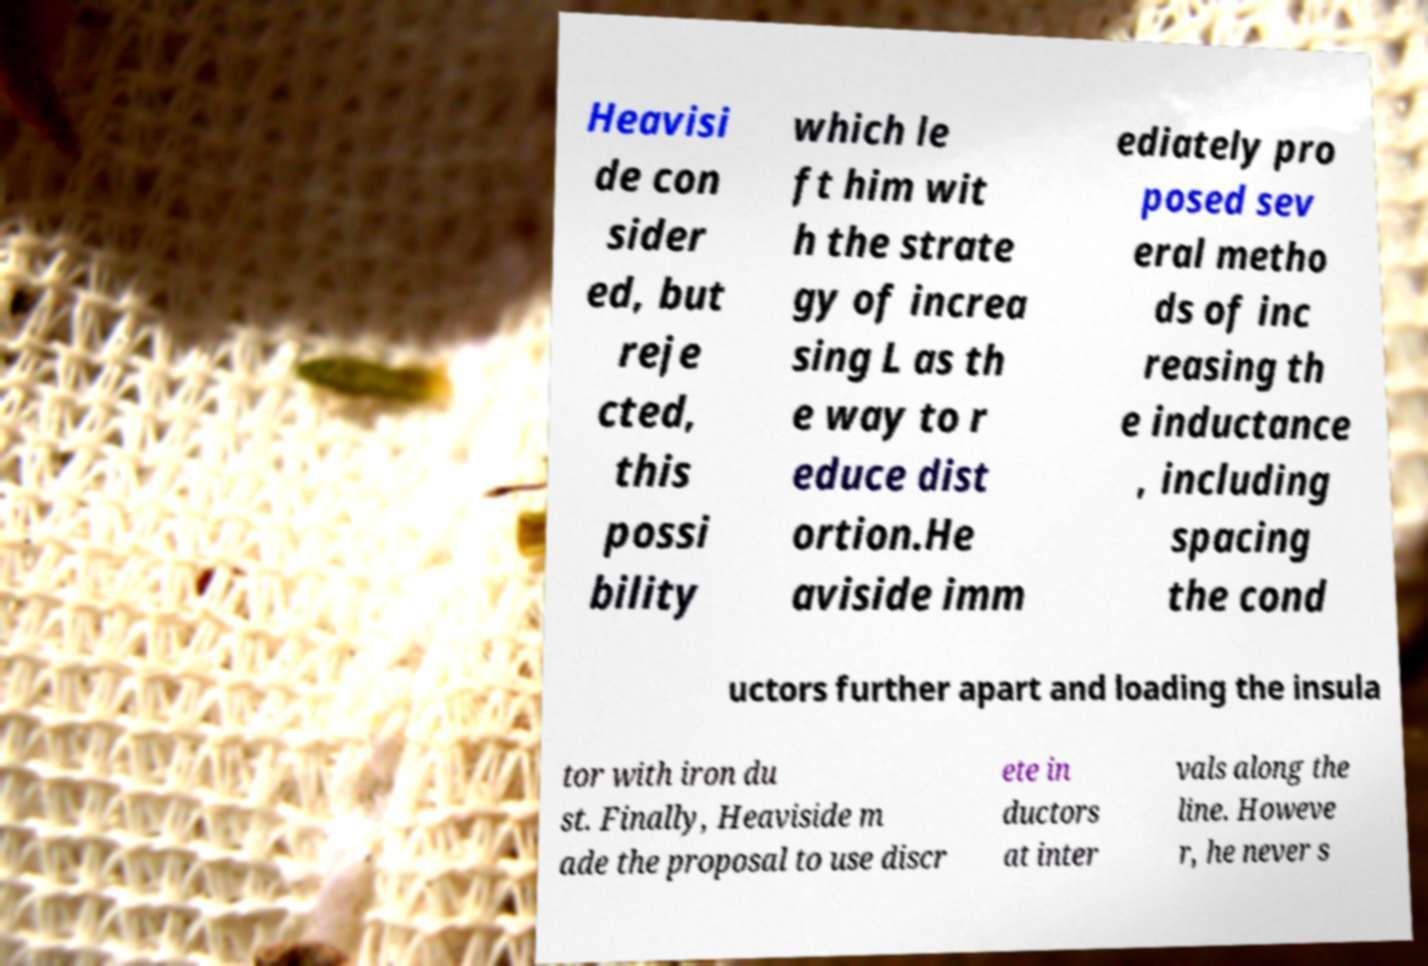I need the written content from this picture converted into text. Can you do that? Heavisi de con sider ed, but reje cted, this possi bility which le ft him wit h the strate gy of increa sing L as th e way to r educe dist ortion.He aviside imm ediately pro posed sev eral metho ds of inc reasing th e inductance , including spacing the cond uctors further apart and loading the insula tor with iron du st. Finally, Heaviside m ade the proposal to use discr ete in ductors at inter vals along the line. Howeve r, he never s 